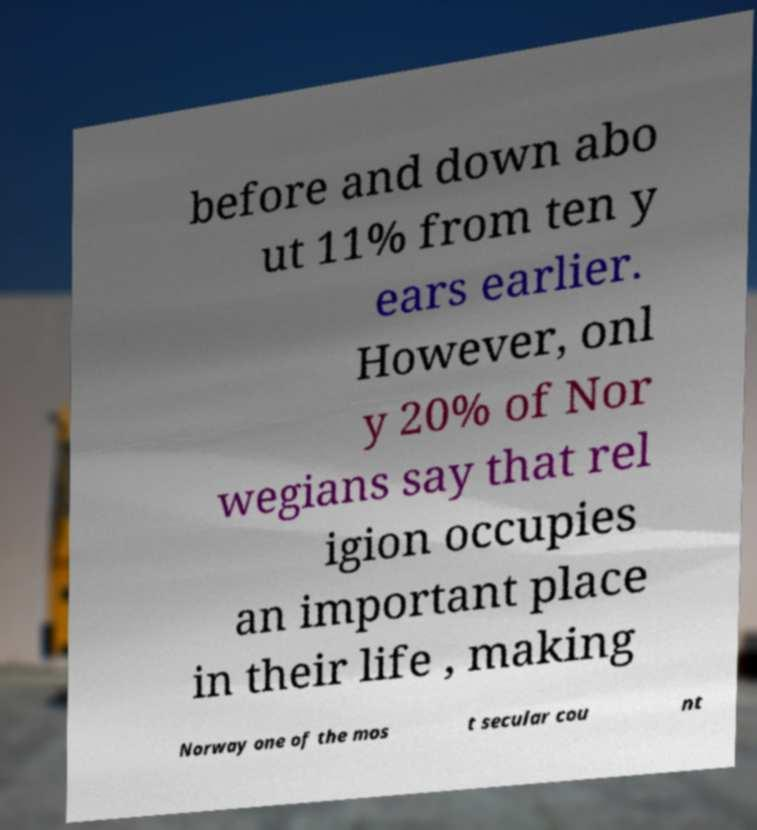What messages or text are displayed in this image? I need them in a readable, typed format. before and down abo ut 11% from ten y ears earlier. However, onl y 20% of Nor wegians say that rel igion occupies an important place in their life , making Norway one of the mos t secular cou nt 